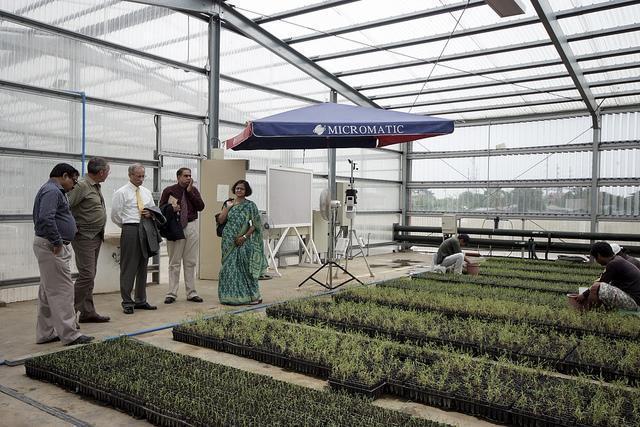How many people are on the landing?
Give a very brief answer. 5. How many people are there?
Give a very brief answer. 6. How many rolls of toilet paper are in the picture?
Give a very brief answer. 0. 